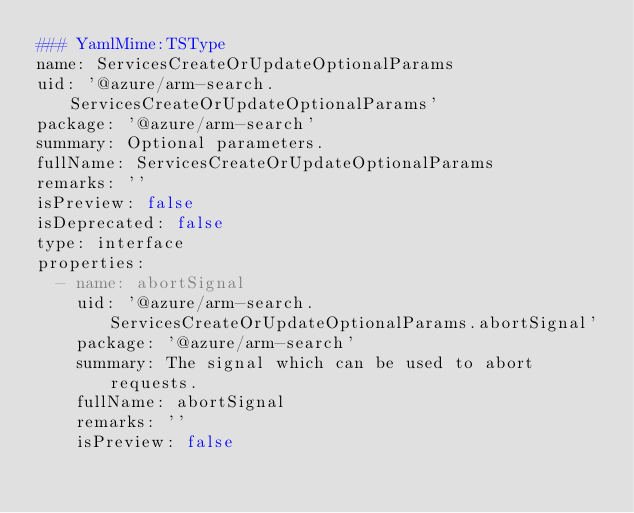Convert code to text. <code><loc_0><loc_0><loc_500><loc_500><_YAML_>### YamlMime:TSType
name: ServicesCreateOrUpdateOptionalParams
uid: '@azure/arm-search.ServicesCreateOrUpdateOptionalParams'
package: '@azure/arm-search'
summary: Optional parameters.
fullName: ServicesCreateOrUpdateOptionalParams
remarks: ''
isPreview: false
isDeprecated: false
type: interface
properties:
  - name: abortSignal
    uid: '@azure/arm-search.ServicesCreateOrUpdateOptionalParams.abortSignal'
    package: '@azure/arm-search'
    summary: The signal which can be used to abort requests.
    fullName: abortSignal
    remarks: ''
    isPreview: false</code> 